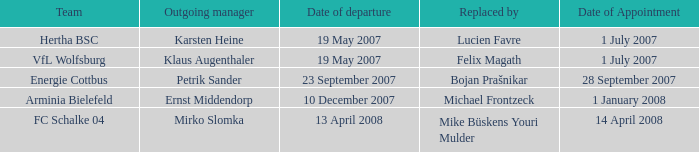When was the departure date when a manager was replaced by Bojan Prašnikar? 23 September 2007. 